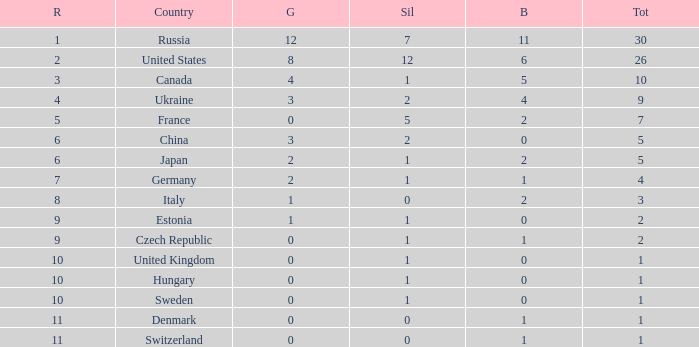What is the largest silver with Gold larger than 4, a Nation of united states, and a Total larger than 26? None. 